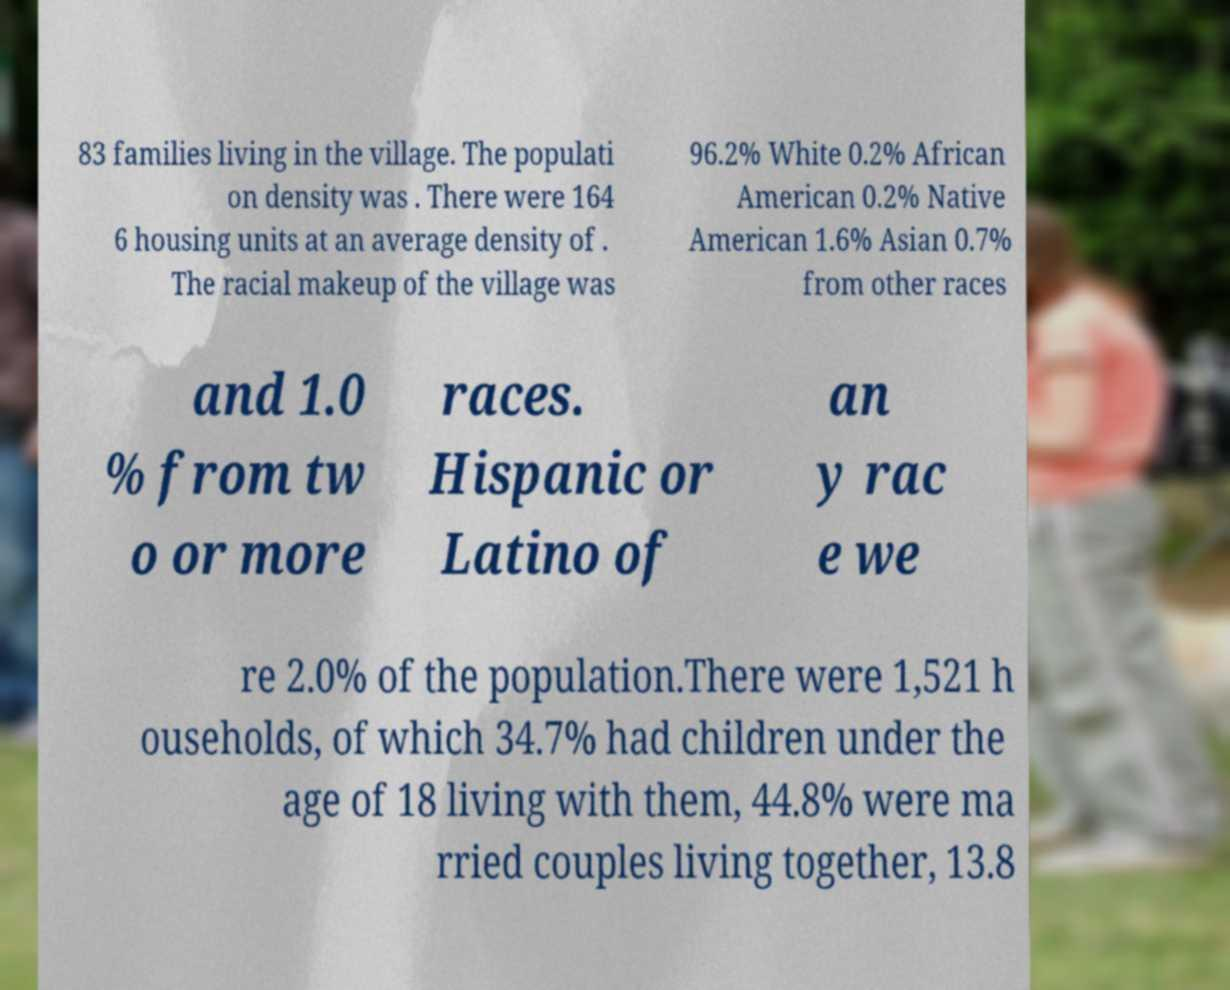Please identify and transcribe the text found in this image. 83 families living in the village. The populati on density was . There were 164 6 housing units at an average density of . The racial makeup of the village was 96.2% White 0.2% African American 0.2% Native American 1.6% Asian 0.7% from other races and 1.0 % from tw o or more races. Hispanic or Latino of an y rac e we re 2.0% of the population.There were 1,521 h ouseholds, of which 34.7% had children under the age of 18 living with them, 44.8% were ma rried couples living together, 13.8 